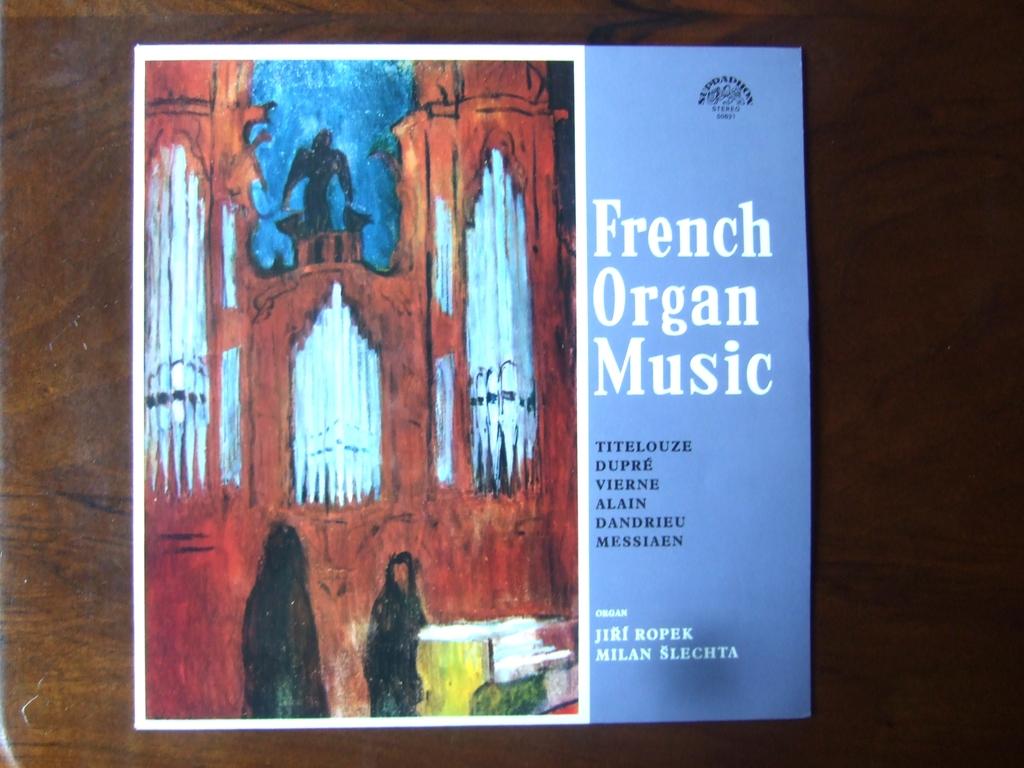What's the name of the song?
Make the answer very short. French organ music. 